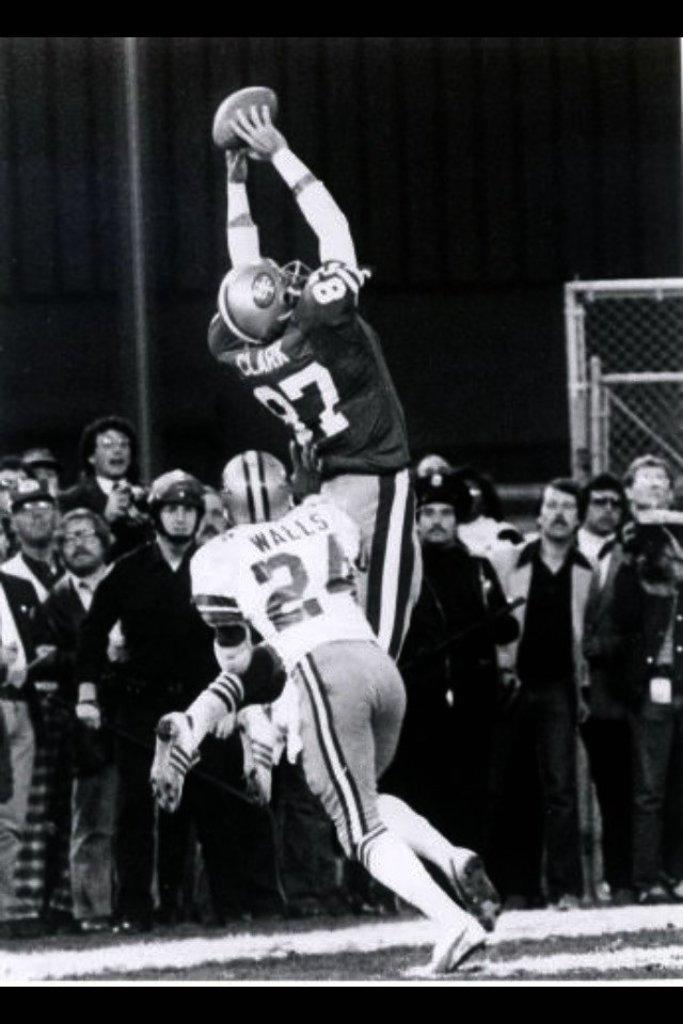Describe this image in one or two sentences. In the middle of this image, there are two persons playing on the ground. In the background, there are other persons watching them, there is a net and a gray colored surface. 